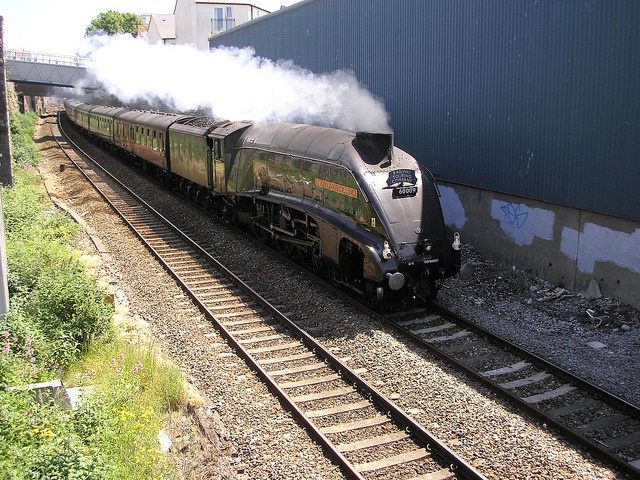Describe the objects in this image and their specific colors. I can see a train in white, black, gray, darkgray, and darkgreen tones in this image. 